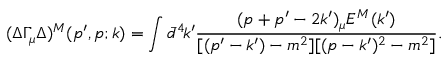<formula> <loc_0><loc_0><loc_500><loc_500>( \Delta \Gamma _ { \mu } \Delta ) ^ { M } ( p ^ { \prime } , p ; k ) = \int \bar { d } ^ { 4 } \, k ^ { \prime } \frac { ( p + p ^ { \prime } - 2 k ^ { \prime } ) _ { \mu } E ^ { M } ( k ^ { \prime } ) } { [ ( p ^ { \prime } - k ^ { \prime } ) - m ^ { 2 } ] [ ( p - k ^ { \prime } ) ^ { 2 } - m ^ { 2 } ] } .</formula> 